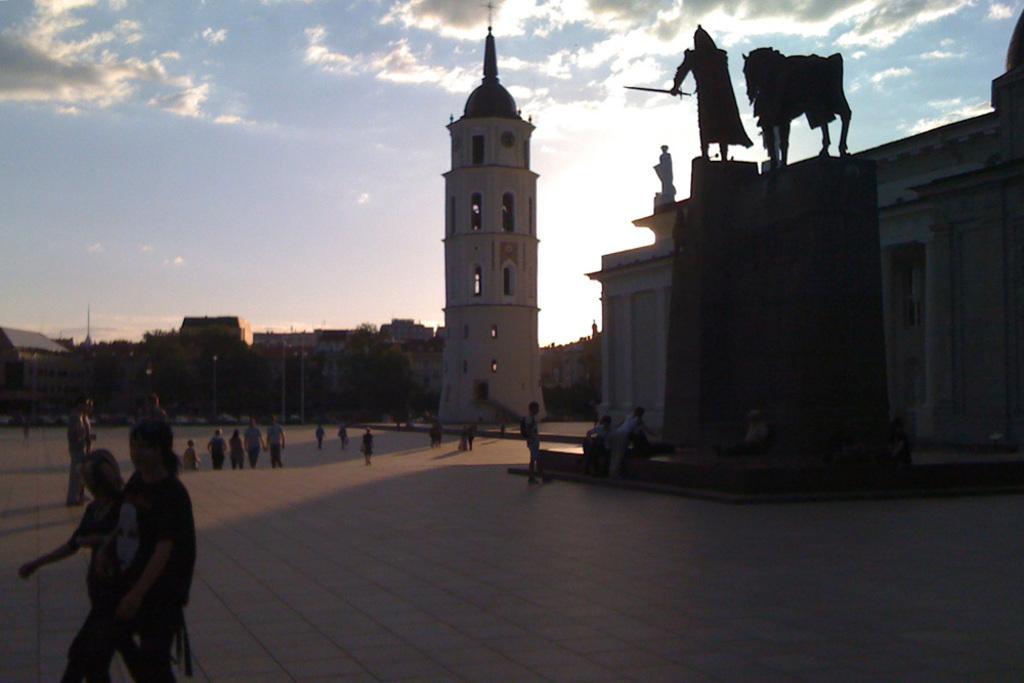Can you describe this image briefly? On the left side, there are two persons walking on the road. On the right side, there are two statues of a wall of a building. Beside this building, there are persons. In the background, there is a tower, which is having windows, there are persons, trees, buildings and there are clouds in the sky. 